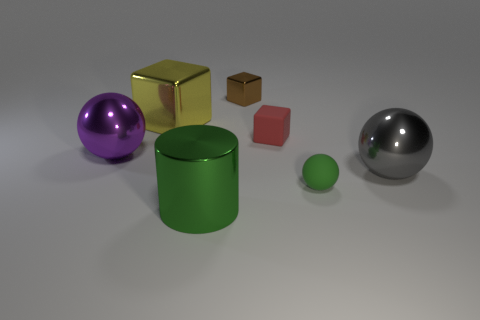Add 2 cyan matte blocks. How many objects exist? 9 Subtract all brown cylinders. Subtract all blue blocks. How many cylinders are left? 1 Subtract all blocks. How many objects are left? 4 Subtract all gray metal things. Subtract all big purple metal spheres. How many objects are left? 5 Add 6 tiny blocks. How many tiny blocks are left? 8 Add 6 matte cubes. How many matte cubes exist? 7 Subtract 0 purple blocks. How many objects are left? 7 